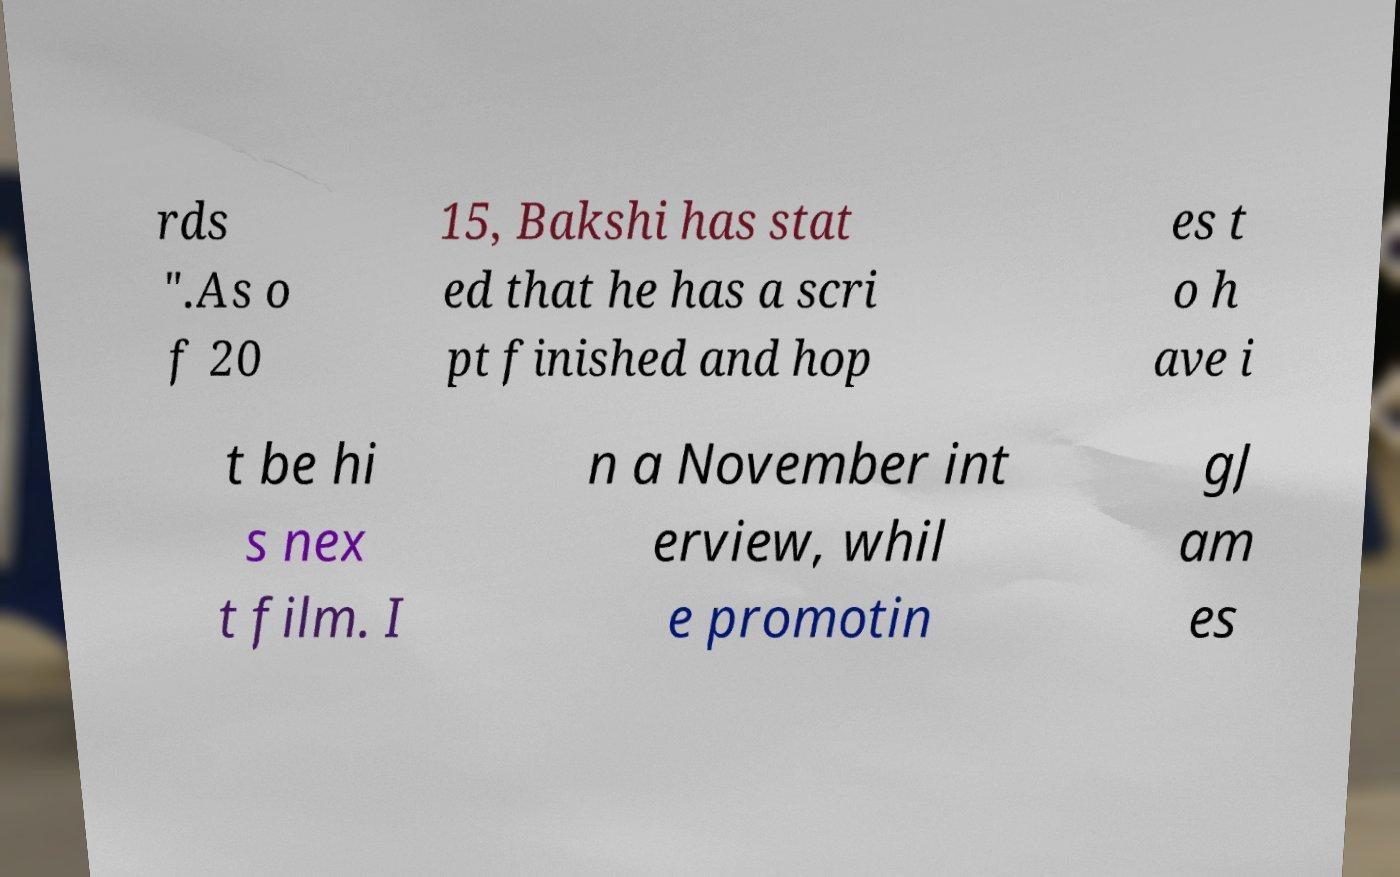There's text embedded in this image that I need extracted. Can you transcribe it verbatim? rds ".As o f 20 15, Bakshi has stat ed that he has a scri pt finished and hop es t o h ave i t be hi s nex t film. I n a November int erview, whil e promotin gJ am es 